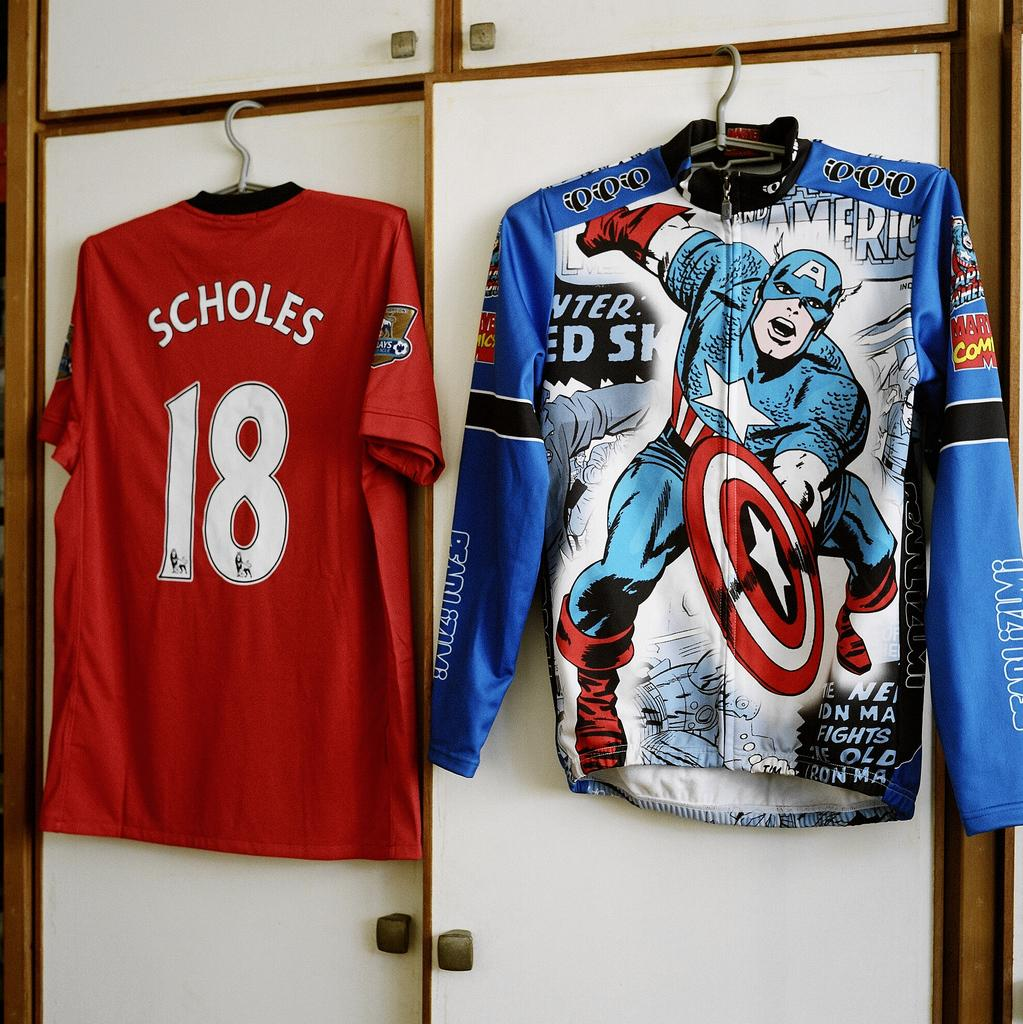<image>
Give a short and clear explanation of the subsequent image. Two shirts hanging on the wall with one that has the number 18 on it. 